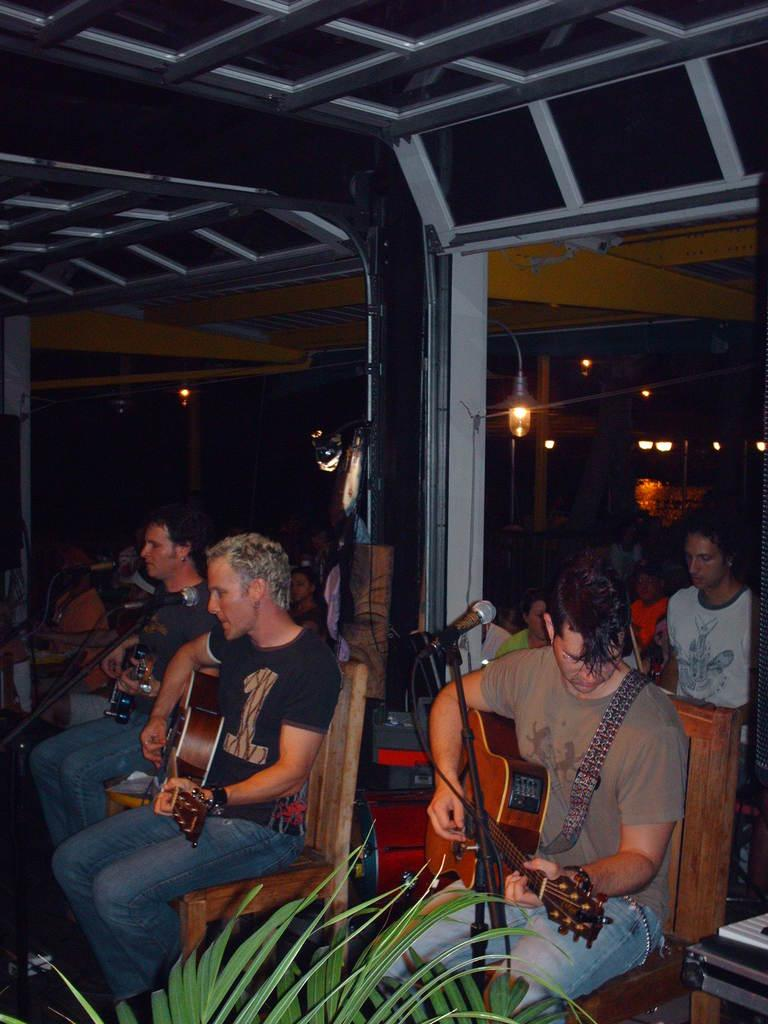How many people are in the image? There is a group of people in the image. What are the people doing in the image? The people are sitting on a chair and playing a guitar. What object is present in the image that is typically used for amplifying sound? There is a microphone in the image. What type of paste is being used by the people in the image? There is no paste present in the image; the people are playing a guitar and sitting on a chair. 